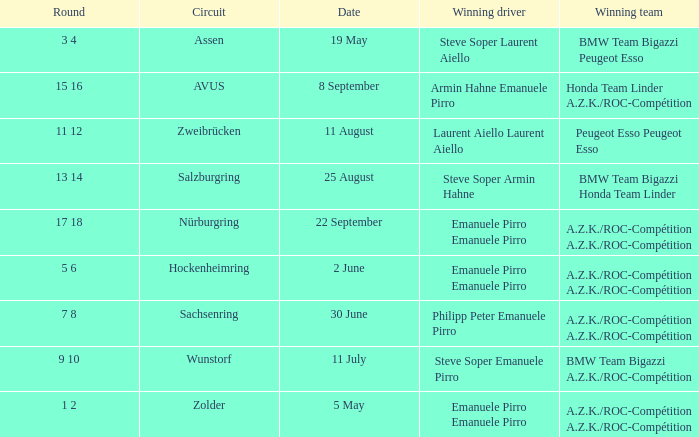What is the round on 30 June with a.z.k./roc-compétition a.z.k./roc-compétition as the winning team? 7 8. 